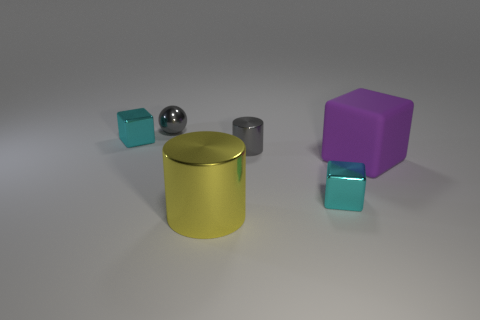Could the arrangement of these objects suggest any particular theme or concept? While it's a simple arrangement, one could interpret themes of diversity and unity among different shapes and colors, or a study of geometric forms and how they interact in a shared space. 